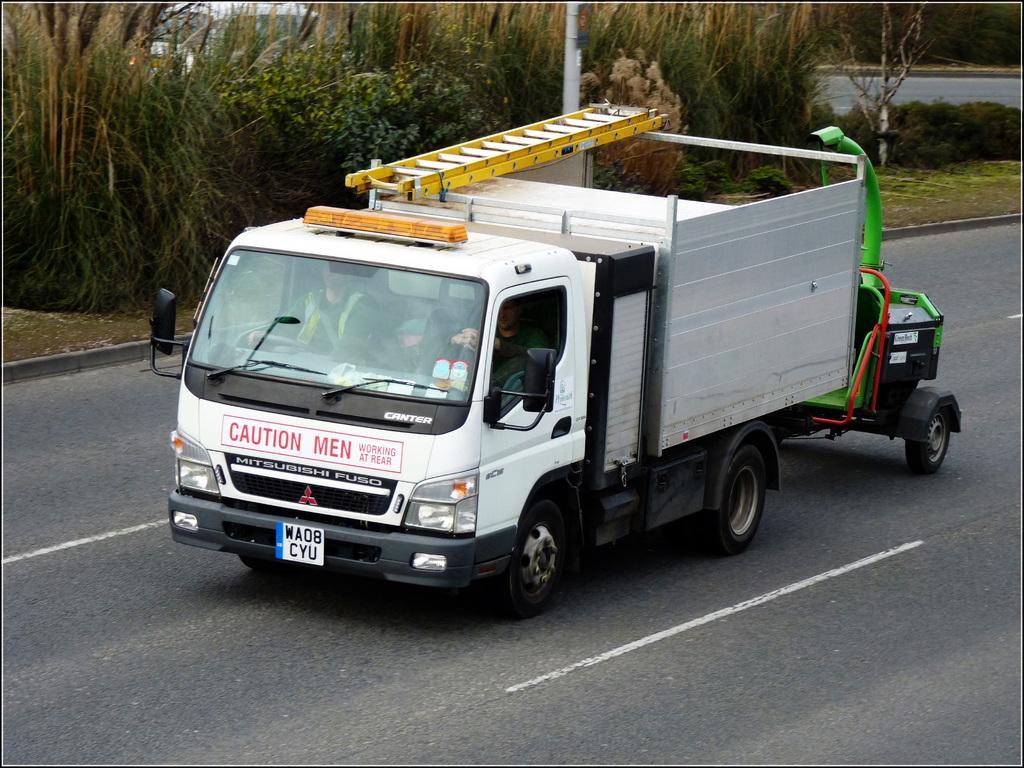How would you summarize this image in a sentence or two? In this picture there is a vehicle on the road and there are few plants and a vehicle in the background. 